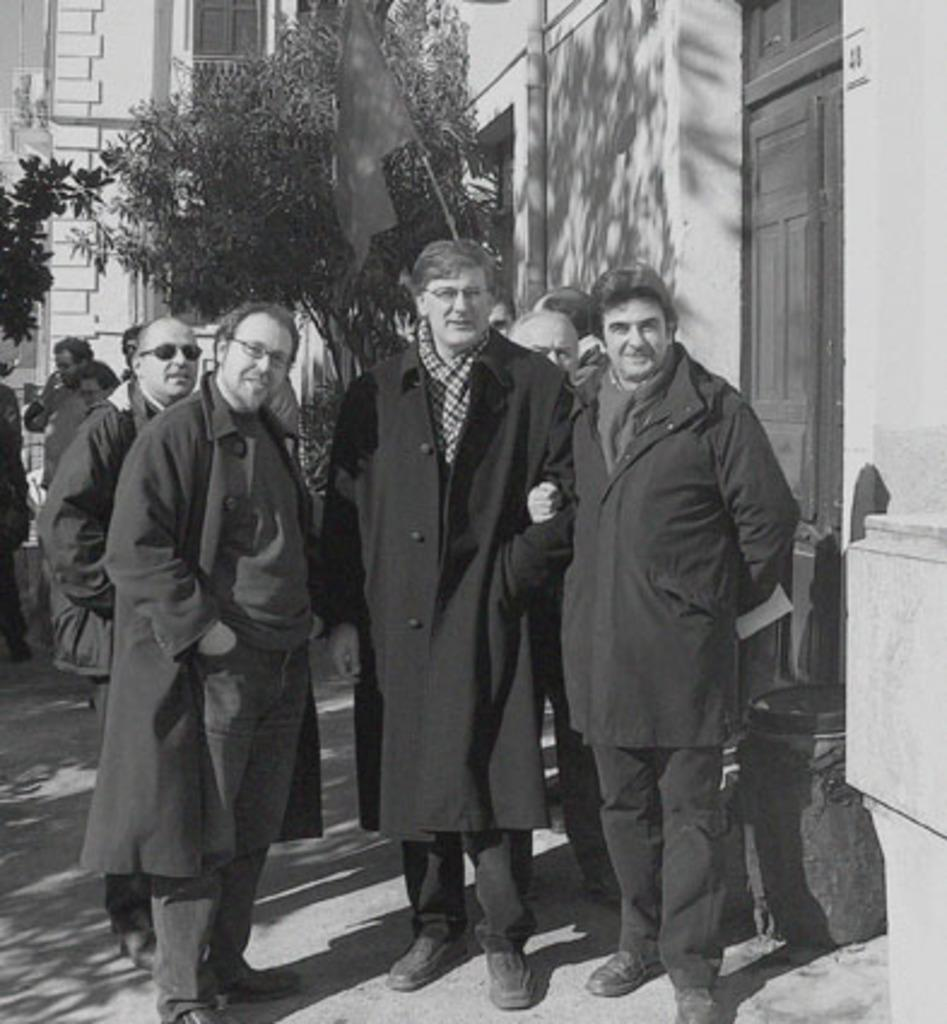How many persons are in the image? There are persons in the image. What color are the dresses worn by the persons? The persons are wearing black color dress. Where are the persons standing in the image? The persons are standing on the ground. What can be seen in the background of the image? There are trees and houses in the background of the image. What type of silver object is being held by the elbow of the person in the image? There is no silver object being held by the elbow of a person in the image. What government policy is being discussed by the persons in the image? There is no indication in the image that the persons are discussing any government policies. 